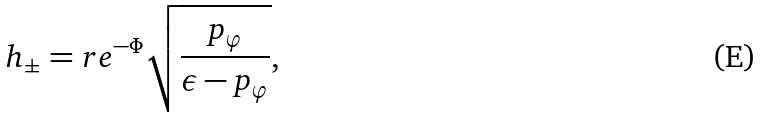Convert formula to latex. <formula><loc_0><loc_0><loc_500><loc_500>h _ { \pm } = r e ^ { - \Phi } \sqrt { \frac { p _ { \varphi } } { \epsilon - p _ { \varphi } } } ,</formula> 